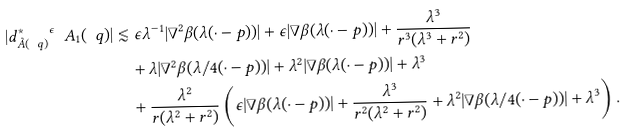Convert formula to latex. <formula><loc_0><loc_0><loc_500><loc_500>| { d _ { \tilde { A } ( \ q ) } ^ { \ast } } ^ { \epsilon } \ A _ { 1 } ( \ q ) | & \lesssim \epsilon \lambda ^ { - 1 } | \nabla ^ { 2 } \beta ( \lambda ( \cdot - p ) ) | + \epsilon | \nabla \beta ( \lambda ( \cdot - p ) ) | + \frac { \lambda ^ { 3 } } { r ^ { 3 } ( \lambda ^ { 3 } + r ^ { 2 } ) } \\ & \quad + \lambda | \nabla ^ { 2 } \beta ( \lambda / 4 ( \cdot - p ) ) | + \lambda ^ { 2 } | \nabla \beta ( \lambda ( \cdot - p ) ) | + \lambda ^ { 3 } \\ & \quad + \frac { \lambda ^ { 2 } } { r ( \lambda ^ { 2 } + r ^ { 2 } ) } \left ( \epsilon | \nabla \beta ( \lambda ( \cdot - p ) ) | + \frac { \lambda ^ { 3 } } { r ^ { 2 } ( \lambda ^ { 2 } + r ^ { 2 } ) } + \lambda ^ { 2 } | \nabla \beta ( \lambda / 4 ( \cdot - p ) ) | + \lambda ^ { 3 } \right ) .</formula> 